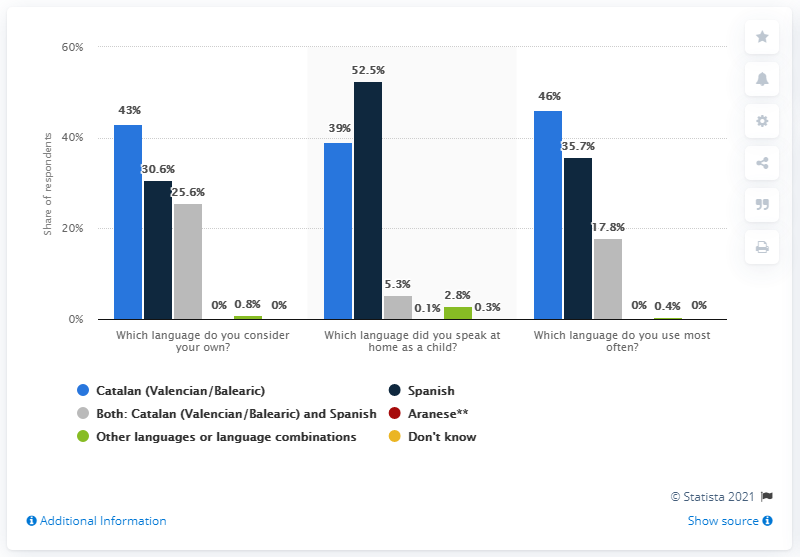Highlight a few significant elements in this photo. The average of all light blue bars is 42.67. The tallest bar value is 52.5. 